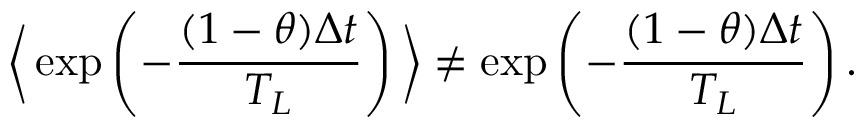<formula> <loc_0><loc_0><loc_500><loc_500>\left \langle \exp \left ( - \frac { ( 1 - \theta ) \Delta t } { T _ { L } } \right ) \right \rangle \neq \exp \left ( - \frac { ( 1 - \theta ) \Delta t } { T _ { L } } \right ) .</formula> 